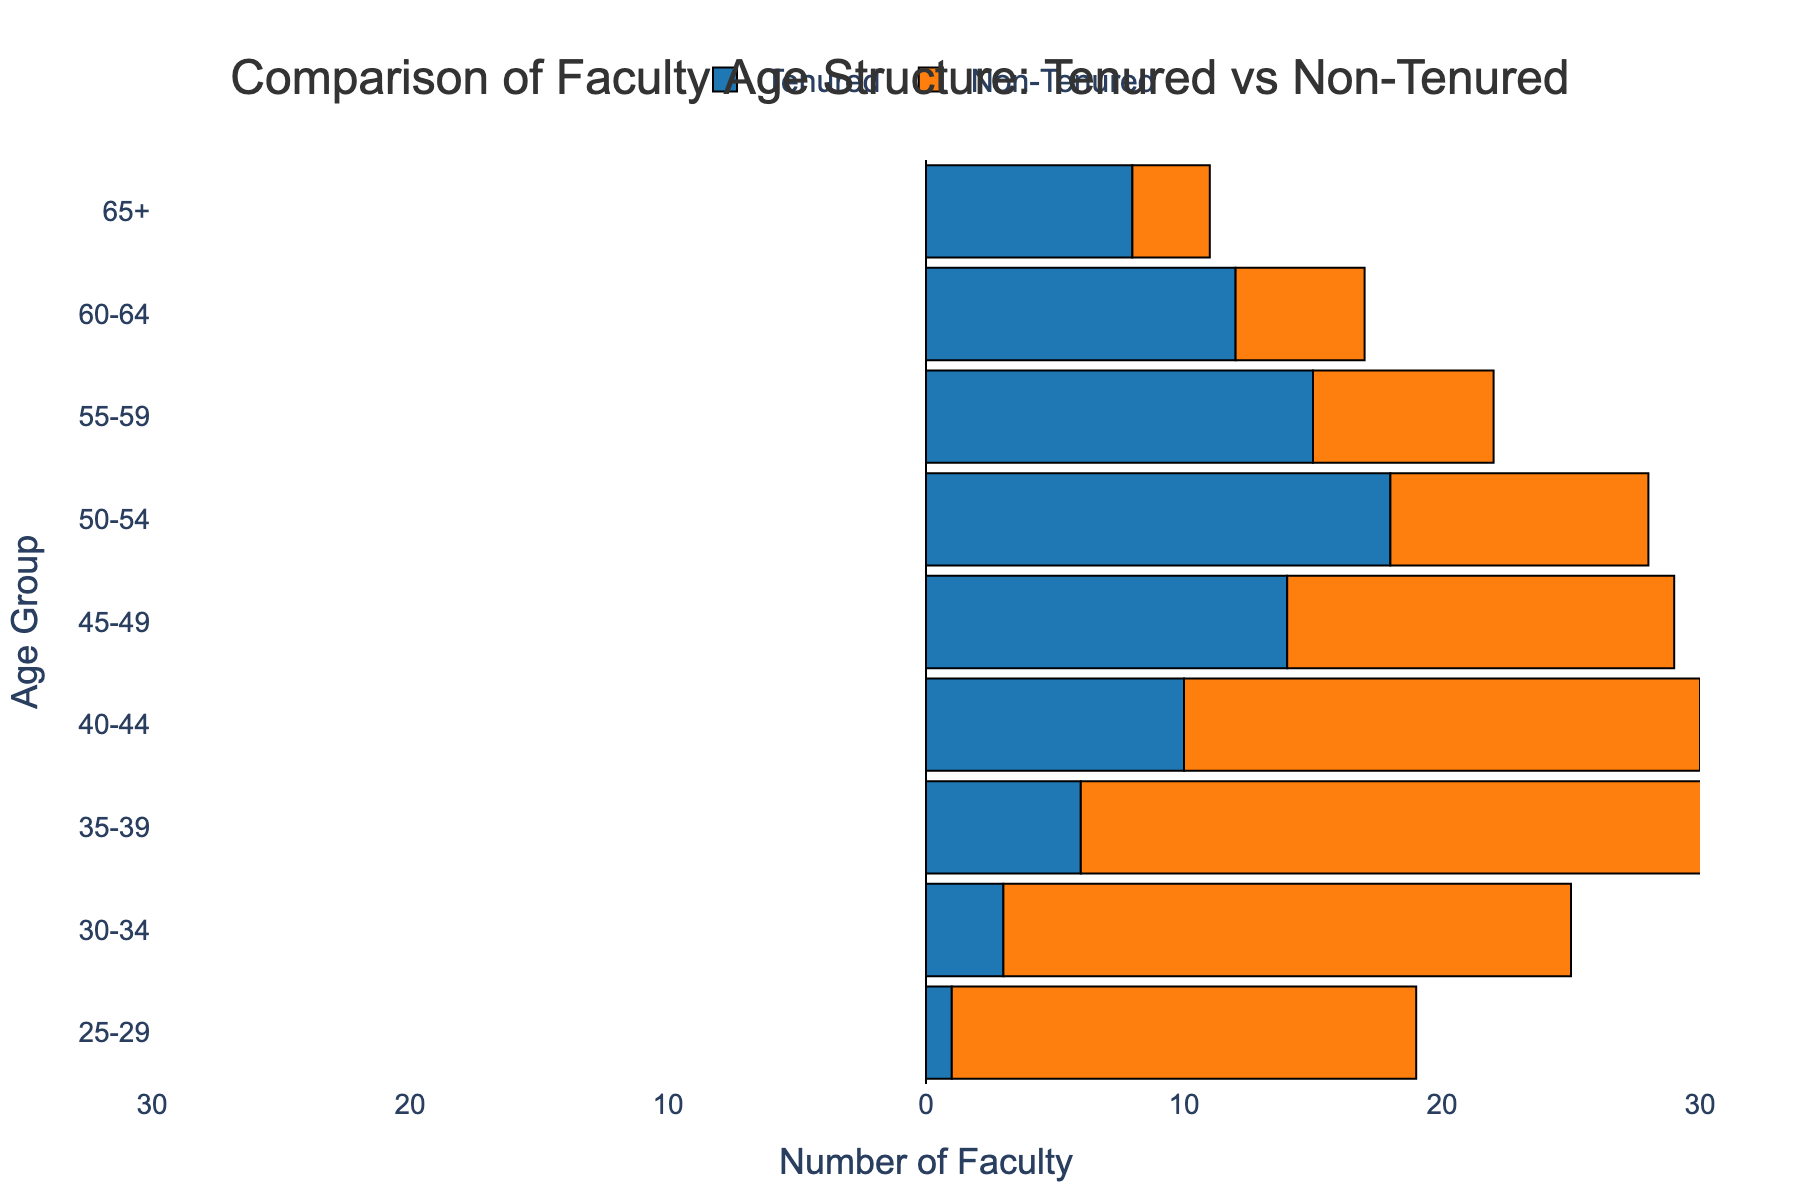What's the title of the figure? The title of the figure is usually placed at the top. By looking at the figure, we can see the text "Comparison of Faculty Age Structure: Tenured vs Non-Tenured".
Answer: Comparison of Faculty Age Structure: Tenured vs Non-Tenured What color represents the tenured faculty? Colors are crucial for differentiating groups in the figure. The tenured faculty are represented by bars in the color blue.
Answer: Blue Which age group has the highest number of tenured faculty? To find the highest number, we go through the bars for tenured faculty and identify the group with the longest bar. The age group 50-54 has the highest number with 18 faculty members.
Answer: 50-54 What is the difference in the number of non-tenured faculty between the age groups 40-44 and 35-39? The number of non-tenured faculty in the 40-44 age group is -20 and in the 35-39 age group is -25. The difference is calculated as -20 - (-25) = 5.
Answer: 5 Which side of the vertical line represents non-tenured faculty? Population pyramids often display categories on either side of a central vertical line. In this figure, the non-tenured faculty are shown on the left side of the vertical line.
Answer: Left How many tenured and non-tenured faculty members are there in the age group 60-64? For the age group 60-64, there are 12 tenured faculty members and 5 non-tenured faculty members. Adding these, we get a total of 17 faculty members.
Answer: 17 In which age group is the difference between tenured and non-tenured faculty most significant? We need to look at each age group and compare the height of the tenured and non-tenured bars. The age group 35-39 has the most significant difference, with tenured at 6 and non-tenured at -25, giving a difference of 31.
Answer: 35-39 Is there any age group where the number of non-tenured faculty is greater than the number of tenured faculty? We compare the values of tenured and non-tenured faculty for each age group. There is no age group where the number of non-tenured faculty is greater than the number of tenured faculty.
Answer: No 